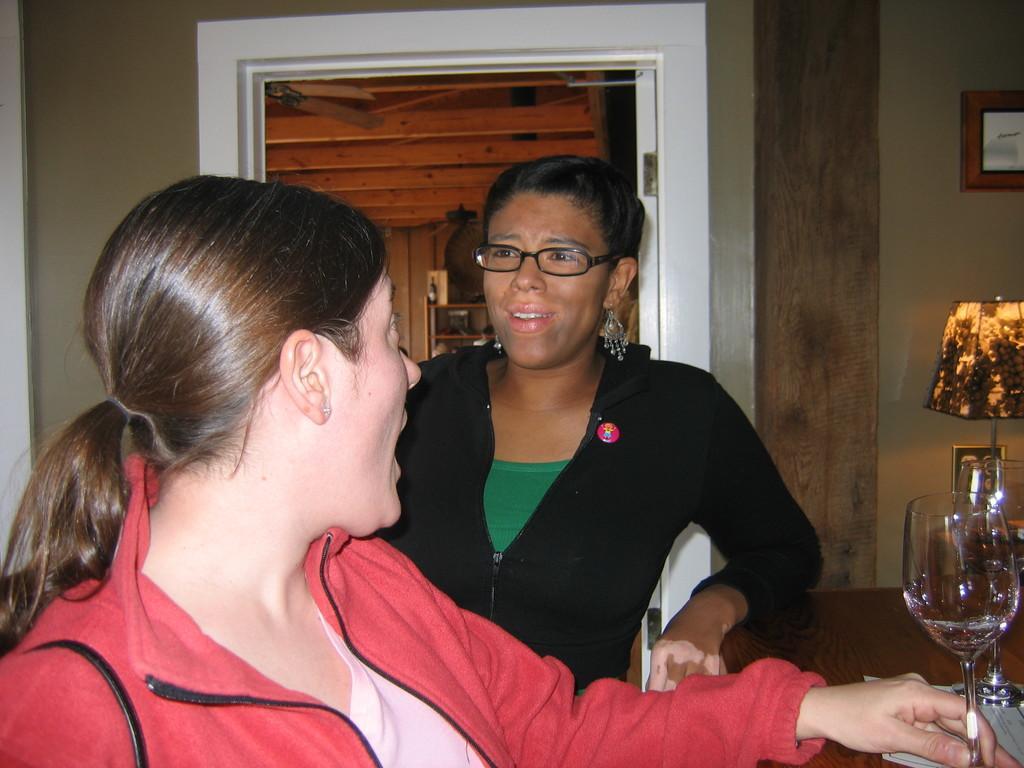How would you summarize this image in a sentence or two? Here we can see 2 persons are standing, and in front here is the table and glass on it, and at back here is the door. 